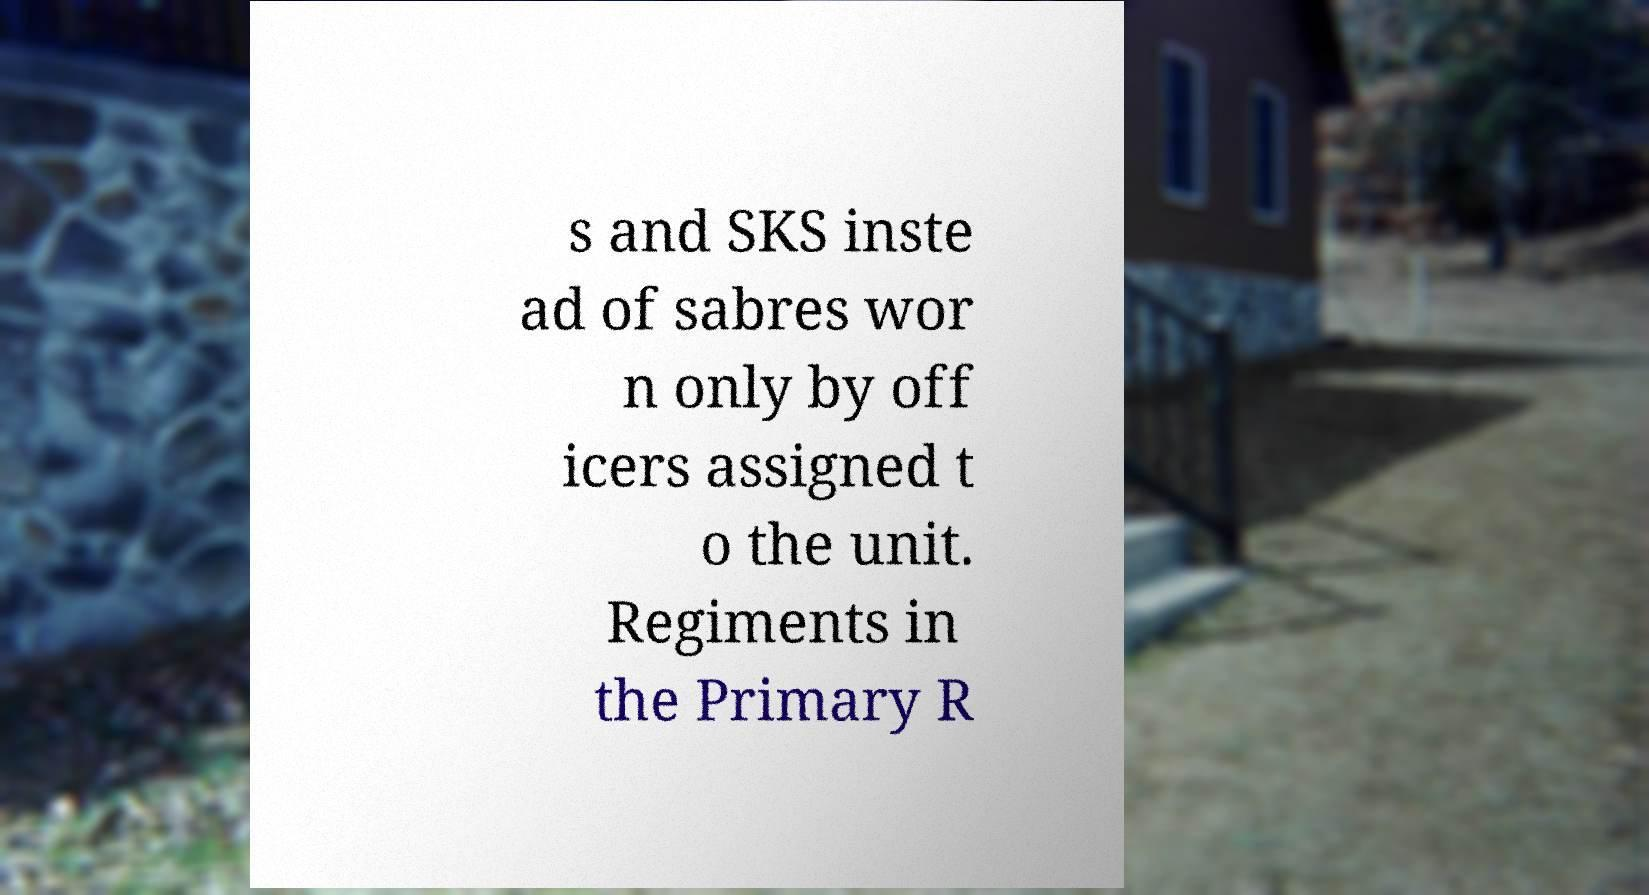There's text embedded in this image that I need extracted. Can you transcribe it verbatim? s and SKS inste ad of sabres wor n only by off icers assigned t o the unit. Regiments in the Primary R 